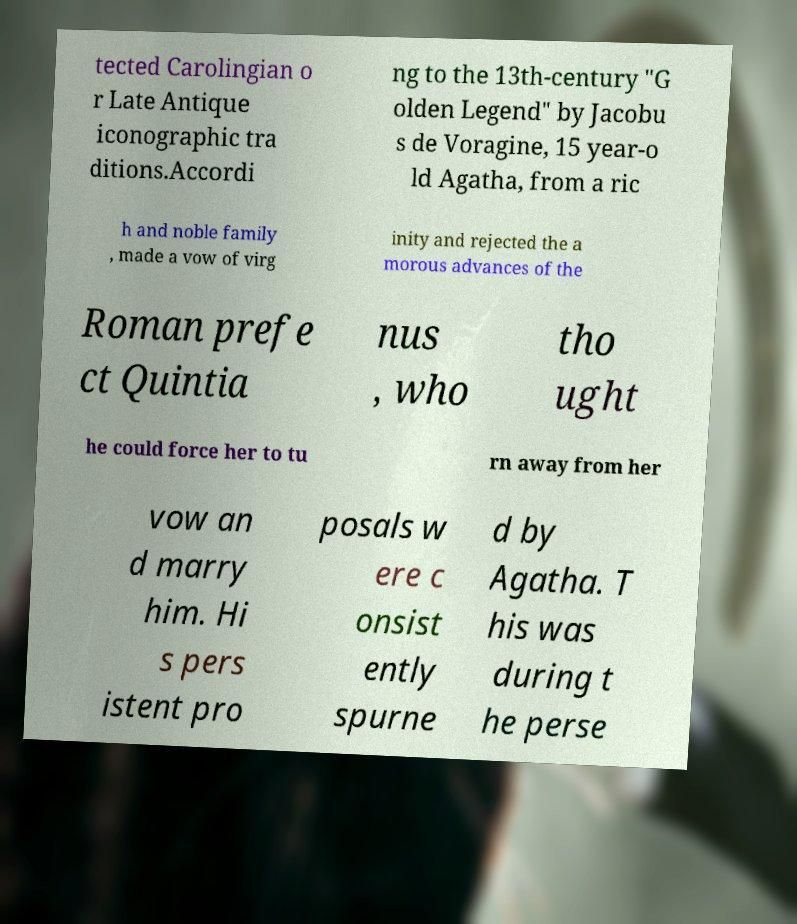What messages or text are displayed in this image? I need them in a readable, typed format. tected Carolingian o r Late Antique iconographic tra ditions.Accordi ng to the 13th-century "G olden Legend" by Jacobu s de Voragine, 15 year-o ld Agatha, from a ric h and noble family , made a vow of virg inity and rejected the a morous advances of the Roman prefe ct Quintia nus , who tho ught he could force her to tu rn away from her vow an d marry him. Hi s pers istent pro posals w ere c onsist ently spurne d by Agatha. T his was during t he perse 